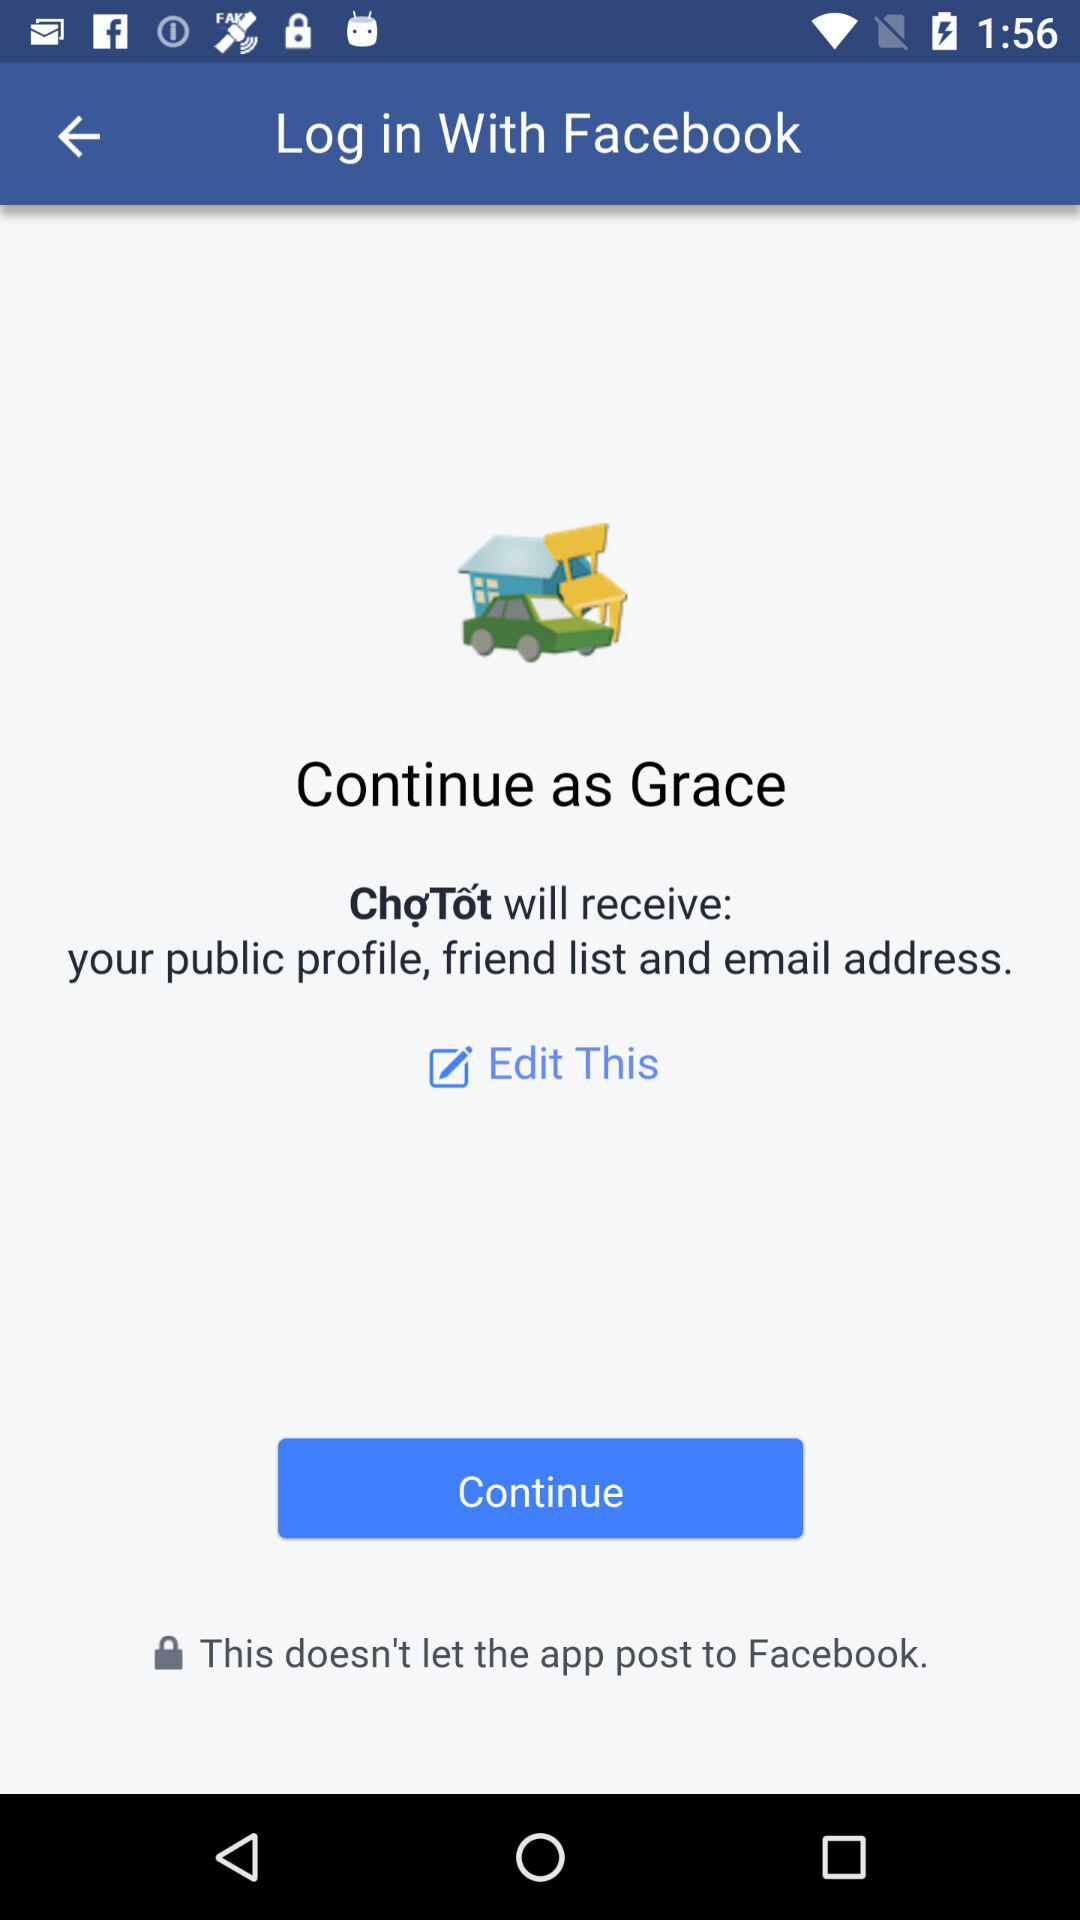What is the name of the user? The name of the user is Grace. 